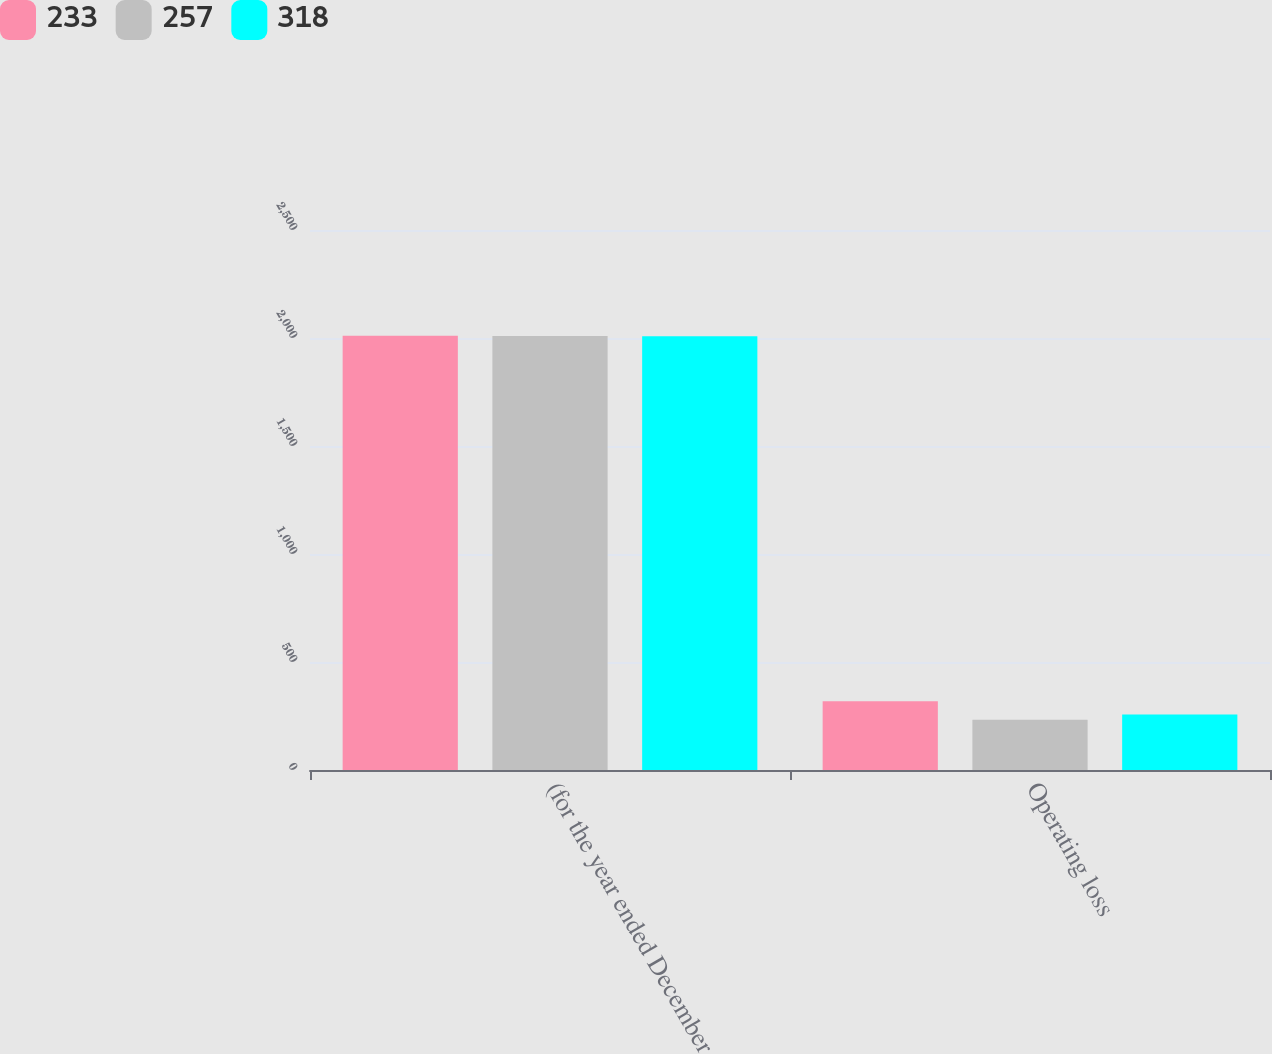<chart> <loc_0><loc_0><loc_500><loc_500><stacked_bar_chart><ecel><fcel>(for the year ended December<fcel>Operating loss<nl><fcel>233<fcel>2010<fcel>318<nl><fcel>257<fcel>2009<fcel>233<nl><fcel>318<fcel>2008<fcel>257<nl></chart> 